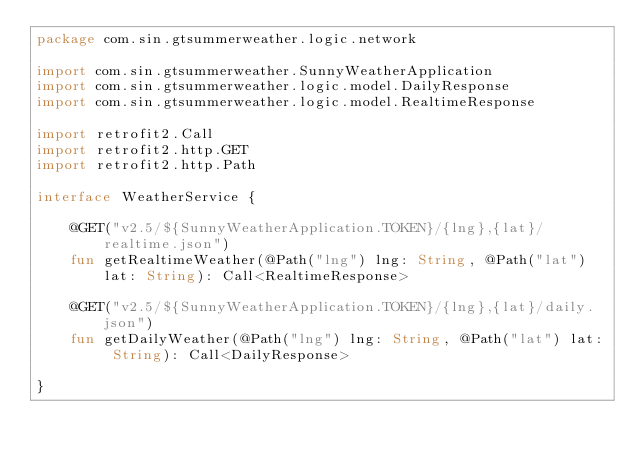Convert code to text. <code><loc_0><loc_0><loc_500><loc_500><_Kotlin_>package com.sin.gtsummerweather.logic.network

import com.sin.gtsummerweather.SunnyWeatherApplication
import com.sin.gtsummerweather.logic.model.DailyResponse
import com.sin.gtsummerweather.logic.model.RealtimeResponse

import retrofit2.Call
import retrofit2.http.GET
import retrofit2.http.Path

interface WeatherService {

    @GET("v2.5/${SunnyWeatherApplication.TOKEN}/{lng},{lat}/realtime.json")
    fun getRealtimeWeather(@Path("lng") lng: String, @Path("lat") lat: String): Call<RealtimeResponse>

    @GET("v2.5/${SunnyWeatherApplication.TOKEN}/{lng},{lat}/daily.json")
    fun getDailyWeather(@Path("lng") lng: String, @Path("lat") lat: String): Call<DailyResponse>

}</code> 